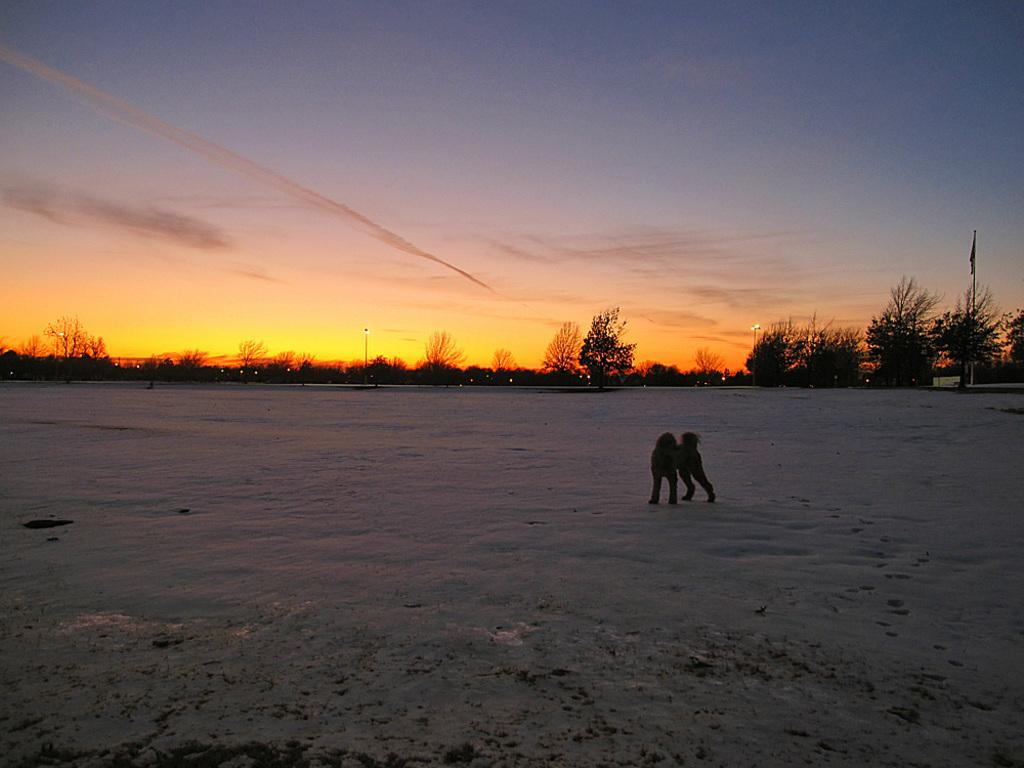What type of animal can be seen in the image? There is an animal in the image, but its specific type cannot be determined from the provided facts. What is the surface on which the animal is standing? The animal is standing on the snow. What can be seen in the background of the image? There are trees and poles in the background of the image. What reason does the pig have for standing on the snow in the image? There is no pig present in the image, and therefore no reason can be attributed to a pig standing on the snow. 